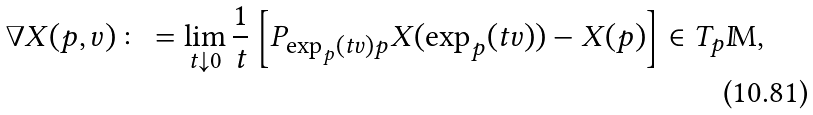<formula> <loc_0><loc_0><loc_500><loc_500>\nabla X ( p , v ) \colon = \lim _ { t \downarrow 0 } \frac { 1 } { t } \left [ P _ { \exp _ { p } ( t v ) p } X ( \exp _ { p } ( t v ) ) - X ( p ) \right ] \in T _ { p } \mathbb { M } ,</formula> 